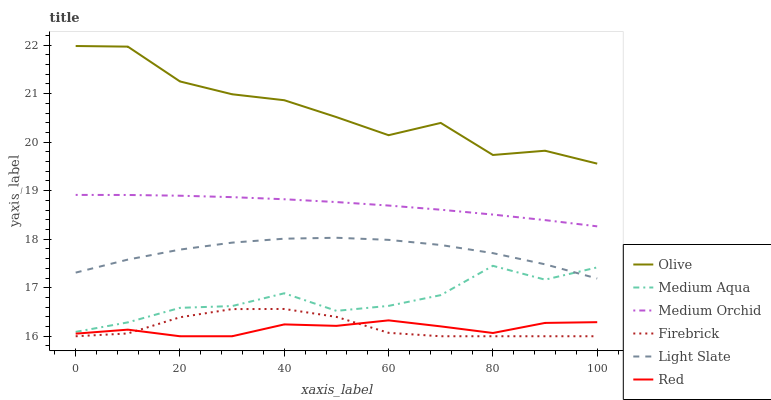Does Red have the minimum area under the curve?
Answer yes or no. Yes. Does Olive have the maximum area under the curve?
Answer yes or no. Yes. Does Firebrick have the minimum area under the curve?
Answer yes or no. No. Does Firebrick have the maximum area under the curve?
Answer yes or no. No. Is Medium Orchid the smoothest?
Answer yes or no. Yes. Is Olive the roughest?
Answer yes or no. Yes. Is Firebrick the smoothest?
Answer yes or no. No. Is Firebrick the roughest?
Answer yes or no. No. Does Medium Orchid have the lowest value?
Answer yes or no. No. Does Firebrick have the highest value?
Answer yes or no. No. Is Firebrick less than Light Slate?
Answer yes or no. Yes. Is Light Slate greater than Red?
Answer yes or no. Yes. Does Firebrick intersect Light Slate?
Answer yes or no. No. 